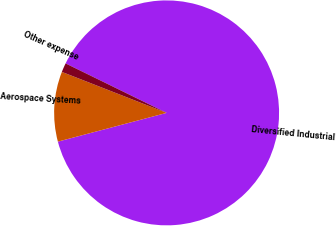<chart> <loc_0><loc_0><loc_500><loc_500><pie_chart><fcel>Diversified Industrial<fcel>Aerospace Systems<fcel>Other expense<nl><fcel>88.64%<fcel>10.05%<fcel>1.31%<nl></chart> 